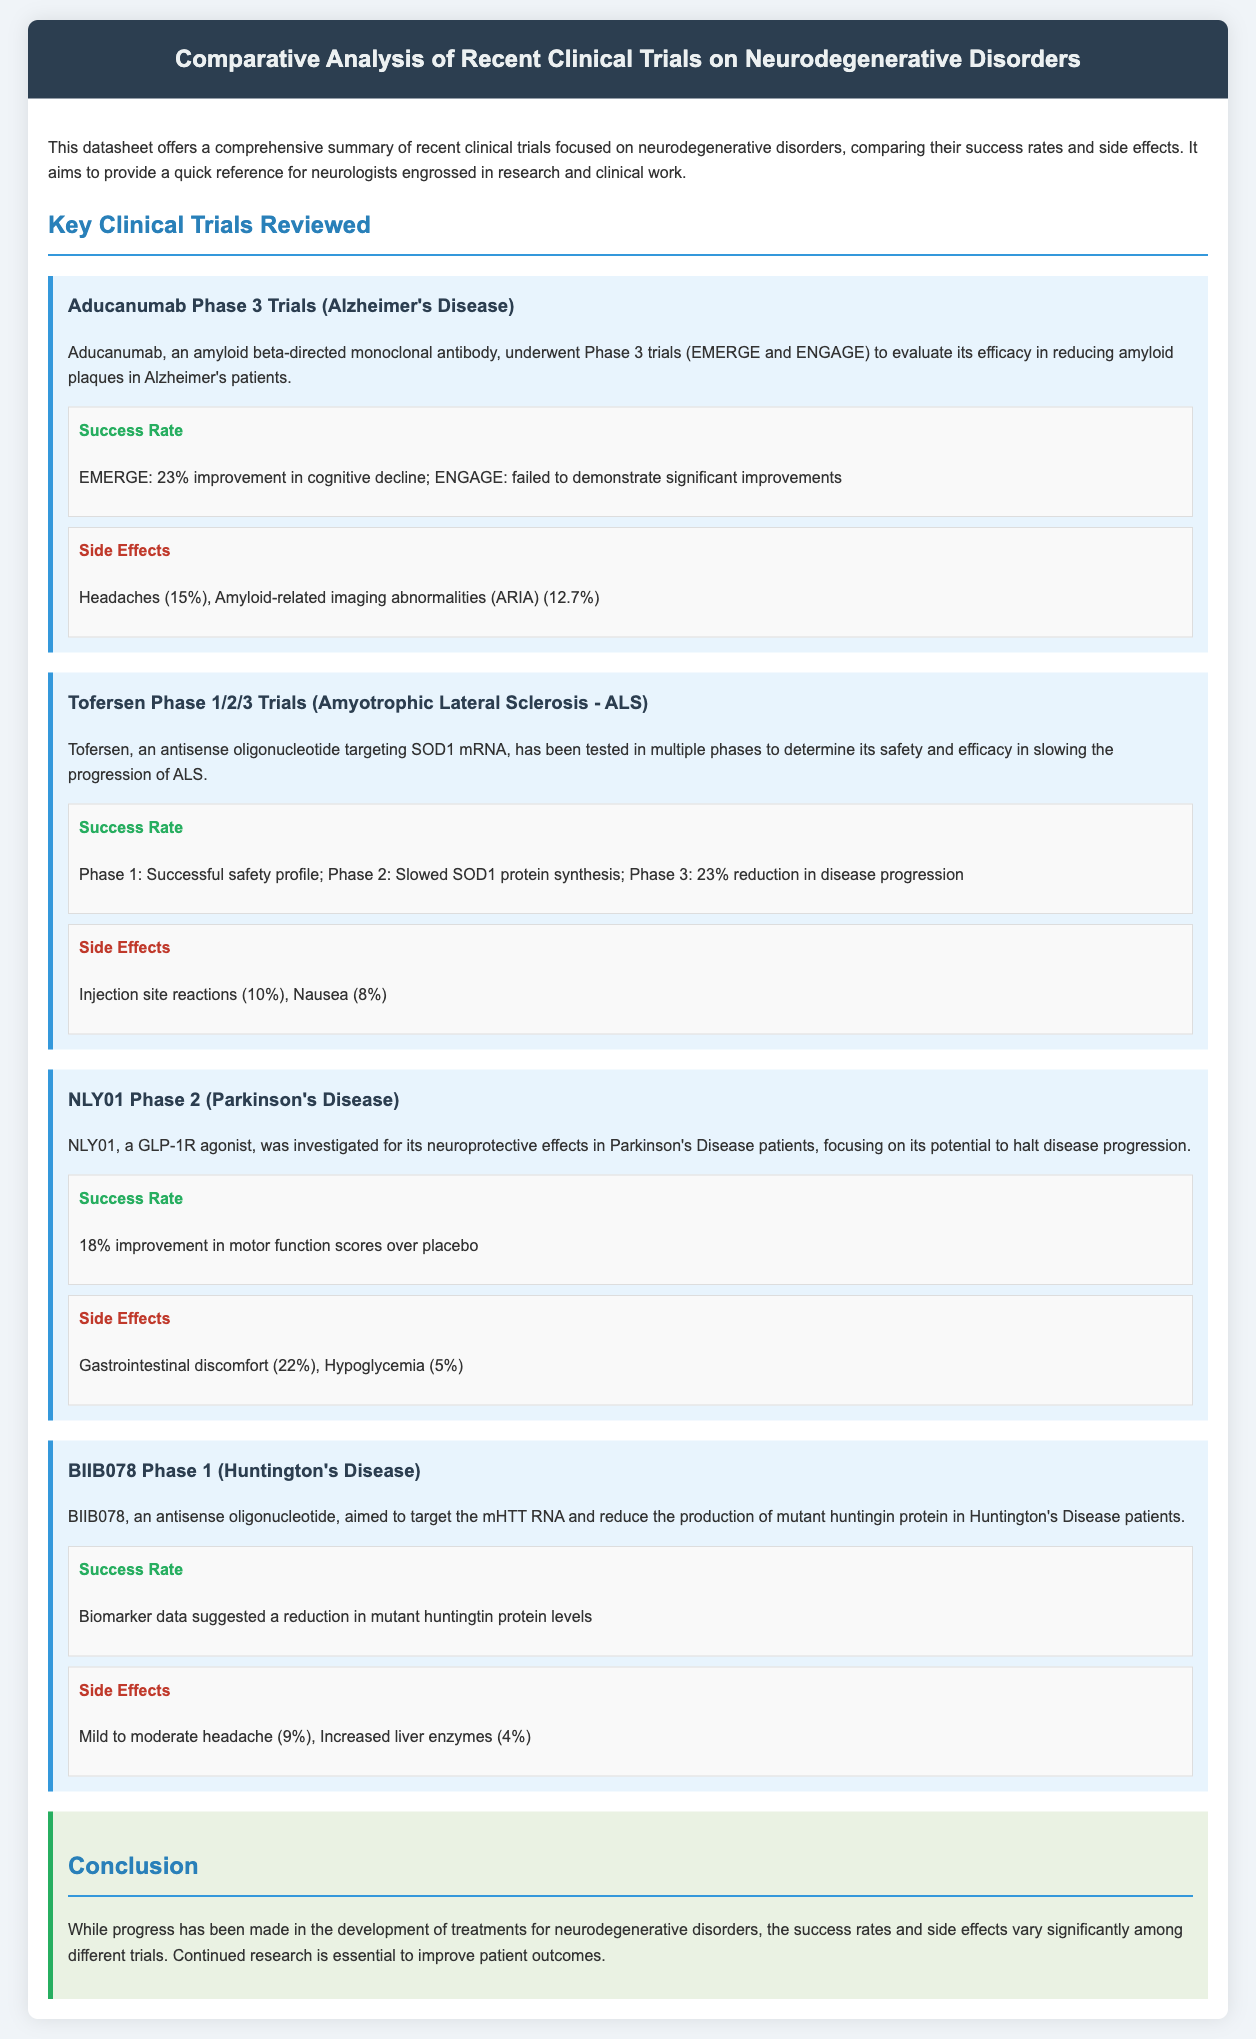What is the success rate of the EMERGE trial for Aducanumab? The success rate for the EMERGE trial is a 23% improvement in cognitive decline.
Answer: 23% What percentage of NLY01 trial participants experienced gastrointestinal discomfort? The NLY01 trial reported that 22% of participants experienced gastrointestinal discomfort.
Answer: 22% What is the primary target of Tofersen? Tofersen targets SOD1 mRNA to slow the progression of ALS.
Answer: SOD1 mRNA How many phases did the Tofersen trials encompass? The Tofersen trials were conducted in multiple phases, specifically Phase 1, Phase 2, and Phase 3.
Answer: Phase 1/2/3 What side effect had the highest reported percentage for Aducanumab? The highest reported side effect for Aducanumab was headaches at 15%.
Answer: Headaches (15%) What was the reported success rate for the BIIB078 trial? The BIIB078 trial suggested a reduction in mutant huntingtin protein levels, without a specific percentage stated.
Answer: Biomarker data Which disorder was the focus of the NLY01 trial? The focus of the NLY01 trial was Parkinson's Disease.
Answer: Parkinson's Disease What was concluded about the variants in success rates across different trials? The conclusion highlights that success rates and side effects vary significantly among different trials.
Answer: Vary significantly What common side effect was reported for the Tofersen trial? Common side effects for the Tofersen trial included injection site reactions and nausea.
Answer: Injection site reactions (10%) What conclusion can be drawn about the development of treatments for neurodegenerative disorders? The conclusion notes the need for continued research to improve patient outcomes.
Answer: Continued research is essential 